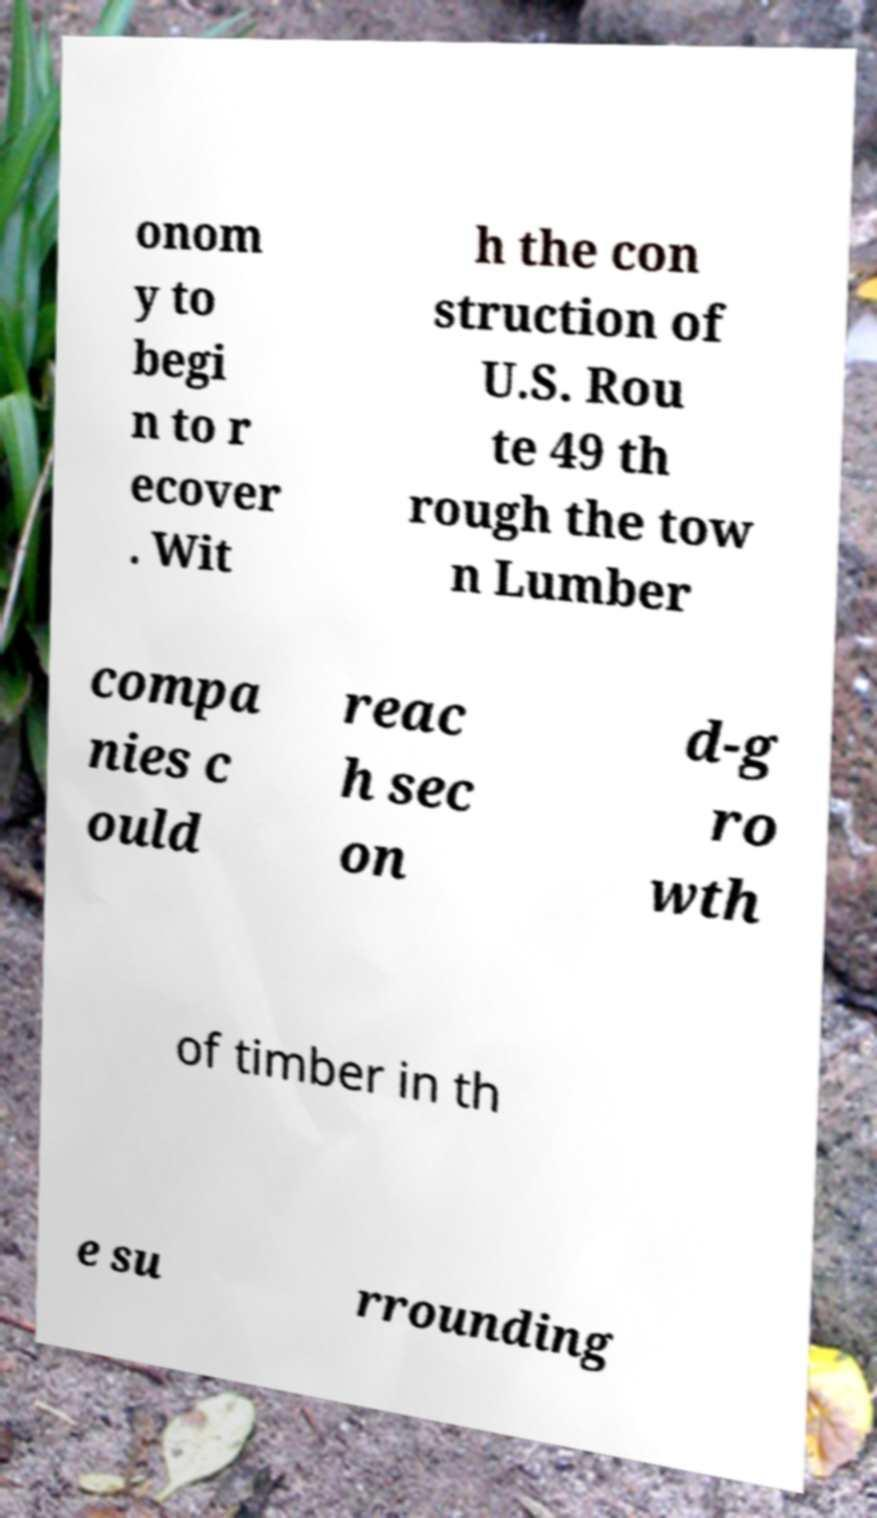There's text embedded in this image that I need extracted. Can you transcribe it verbatim? onom y to begi n to r ecover . Wit h the con struction of U.S. Rou te 49 th rough the tow n Lumber compa nies c ould reac h sec on d-g ro wth of timber in th e su rrounding 